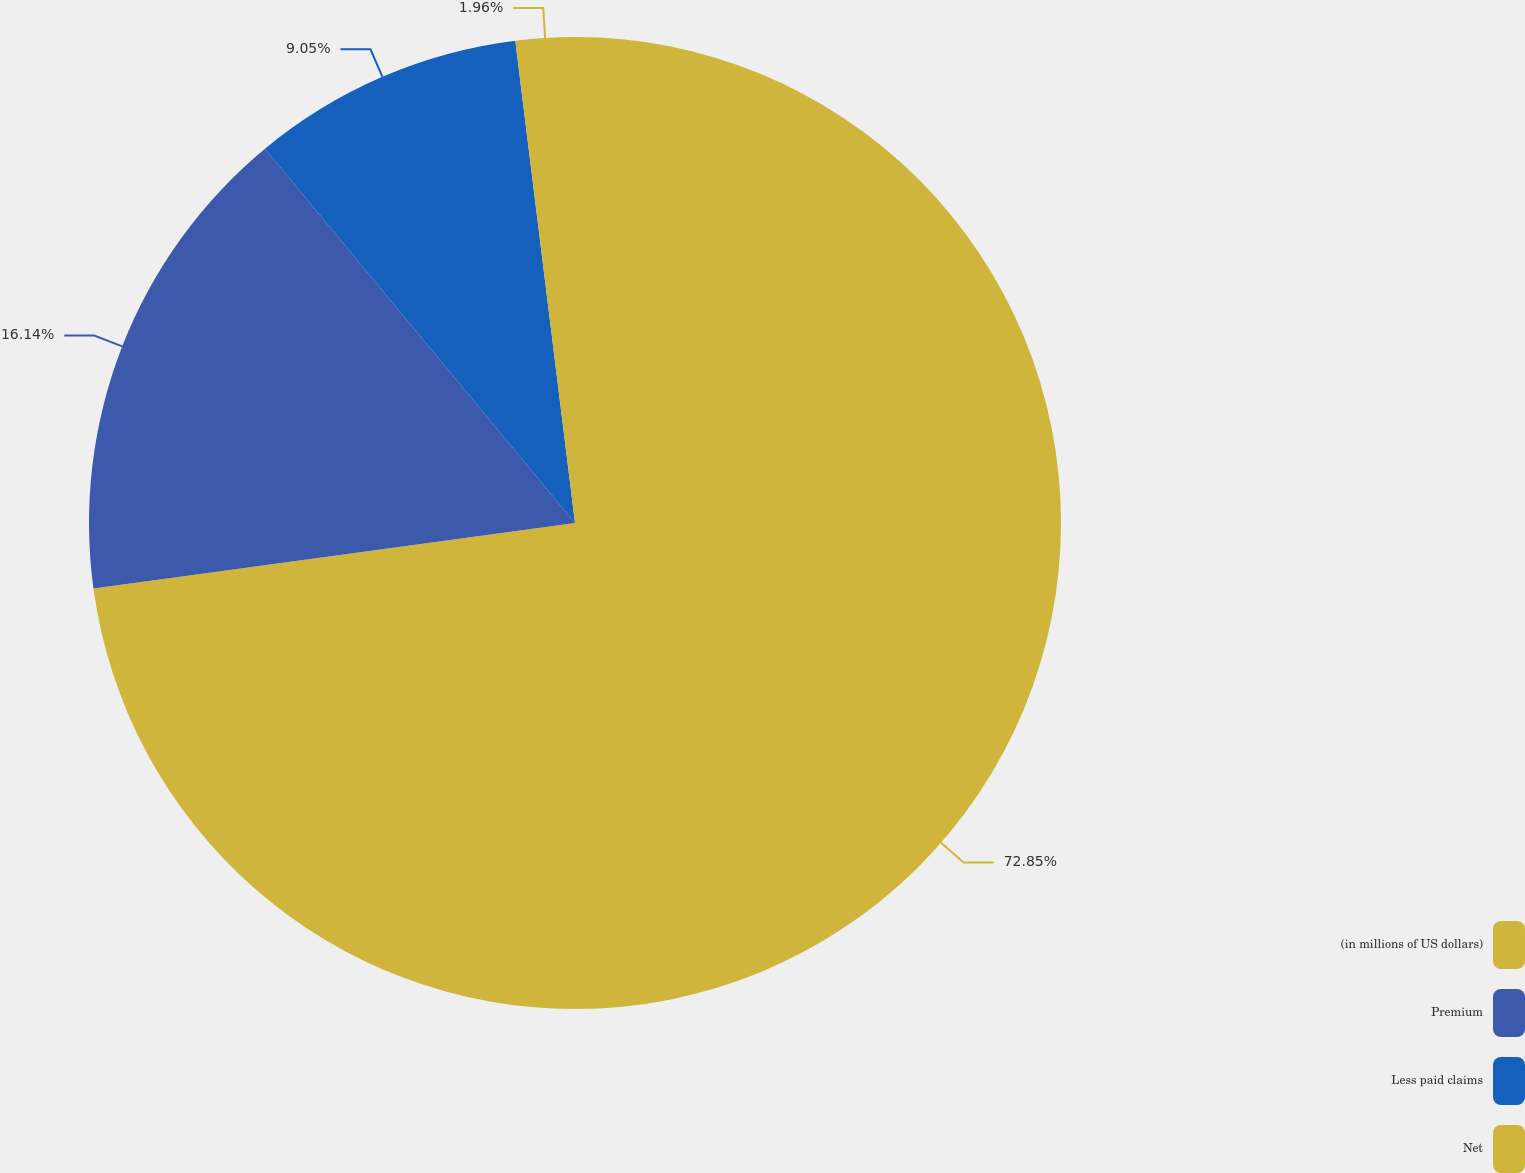Convert chart to OTSL. <chart><loc_0><loc_0><loc_500><loc_500><pie_chart><fcel>(in millions of US dollars)<fcel>Premium<fcel>Less paid claims<fcel>Net<nl><fcel>72.85%<fcel>16.14%<fcel>9.05%<fcel>1.96%<nl></chart> 